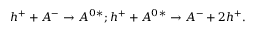<formula> <loc_0><loc_0><loc_500><loc_500>{ h ^ { + } } + { A ^ { - } } \rightarrow A ^ { 0 } { ^ { * } } ; { h ^ { + } } + { A ^ { 0 } { ^ { * } } } \rightarrow A ^ { - } + 2 { h ^ { + } } .</formula> 